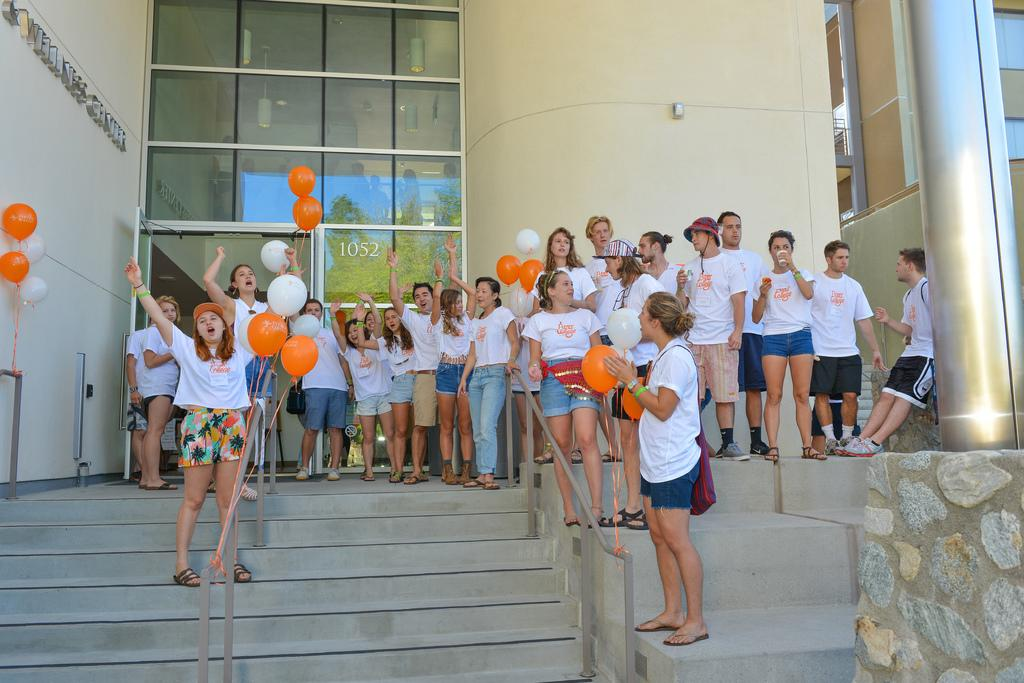What can be seen in the image involving people? There are people standing in the image. What decorative or festive items are present in the image? There are balloons in the image. What architectural feature can be seen in the background of the image? There is a wall in the background of the image. What material is visible in the image? There is glass visible in the image. What feature is present at the bottom of the image? There are stairs at the bottom of the image. What type of bone can be seen in the image? There is no bone present in the image. What is the temperature of the frog in the image? There is no frog present in the image. 